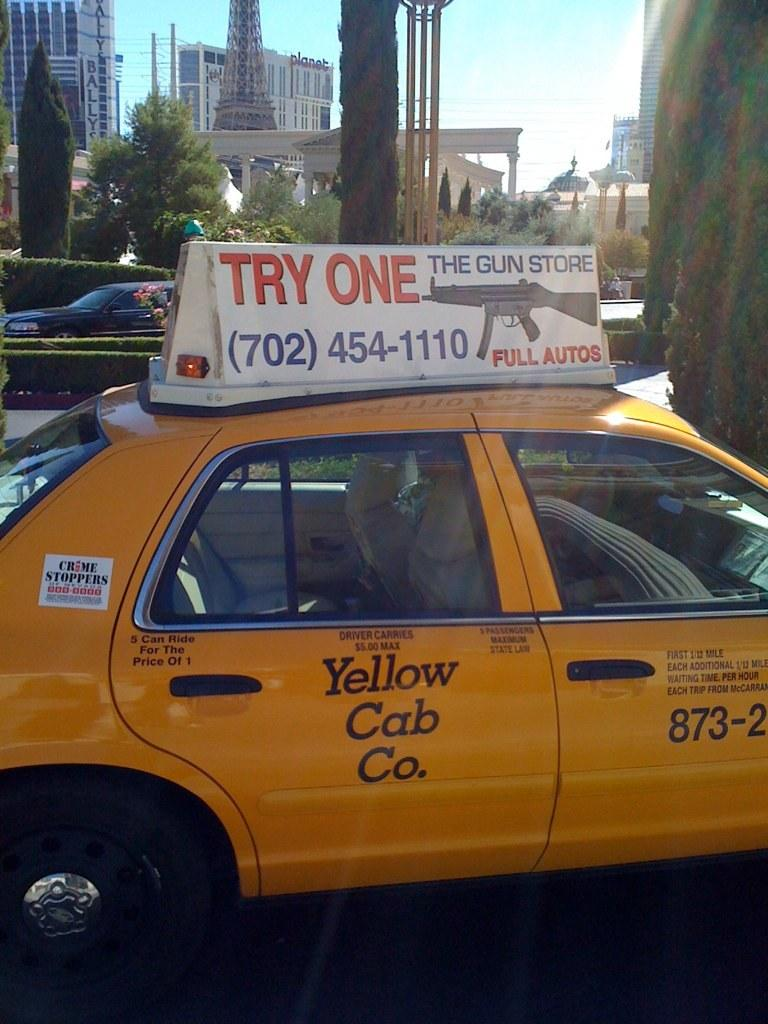<image>
Share a concise interpretation of the image provided. An advertisement for automatic guns is on top of a yellow taxi cab. 